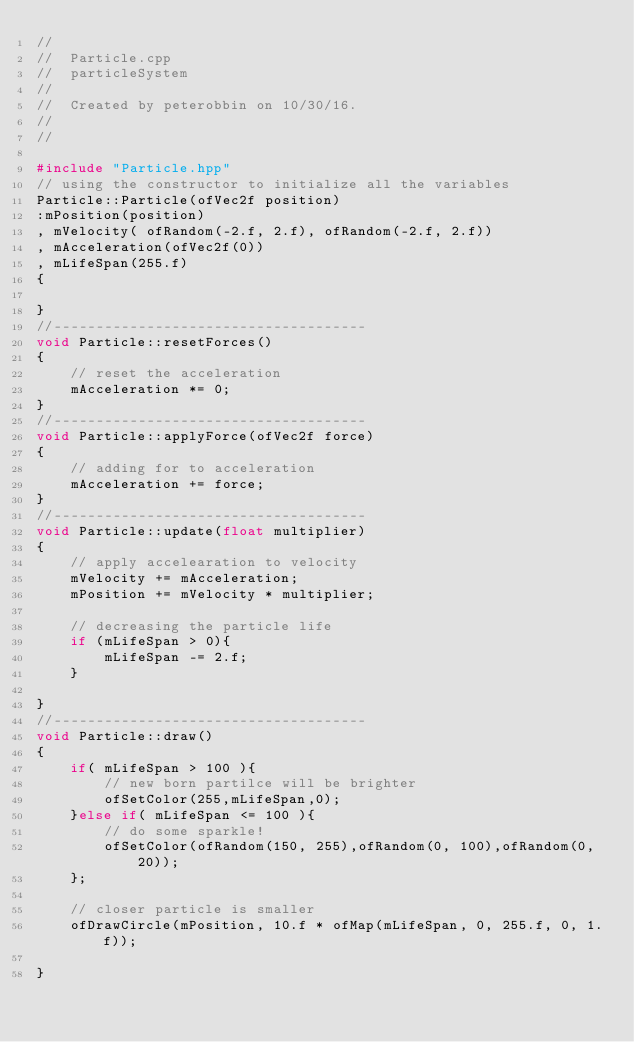Convert code to text. <code><loc_0><loc_0><loc_500><loc_500><_C++_>//
//  Particle.cpp
//  particleSystem
//
//  Created by peterobbin on 10/30/16.
//
//

#include "Particle.hpp"
// using the constructor to initialize all the variables
Particle::Particle(ofVec2f position)
:mPosition(position)
, mVelocity( ofRandom(-2.f, 2.f), ofRandom(-2.f, 2.f))
, mAcceleration(ofVec2f(0))
, mLifeSpan(255.f)
{

}
//-------------------------------------
void Particle::resetForces()
{
    // reset the acceleration
    mAcceleration *= 0;
}
//-------------------------------------
void Particle::applyForce(ofVec2f force)
{
    // adding for to acceleration
    mAcceleration += force;
}
//-------------------------------------
void Particle::update(float multiplier)
{
    // apply accelearation to velocity
    mVelocity += mAcceleration;
    mPosition += mVelocity * multiplier;
    
    // decreasing the particle life
    if (mLifeSpan > 0){
        mLifeSpan -= 2.f;
    }
    
}
//-------------------------------------
void Particle::draw()
{
    if( mLifeSpan > 100 ){
        // new born partilce will be brighter
        ofSetColor(255,mLifeSpan,0);
    }else if( mLifeSpan <= 100 ){
        // do some sparkle!
        ofSetColor(ofRandom(150, 255),ofRandom(0, 100),ofRandom(0, 20));
    };
    
    // closer particle is smaller
    ofDrawCircle(mPosition, 10.f * ofMap(mLifeSpan, 0, 255.f, 0, 1.f));
    
}
</code> 